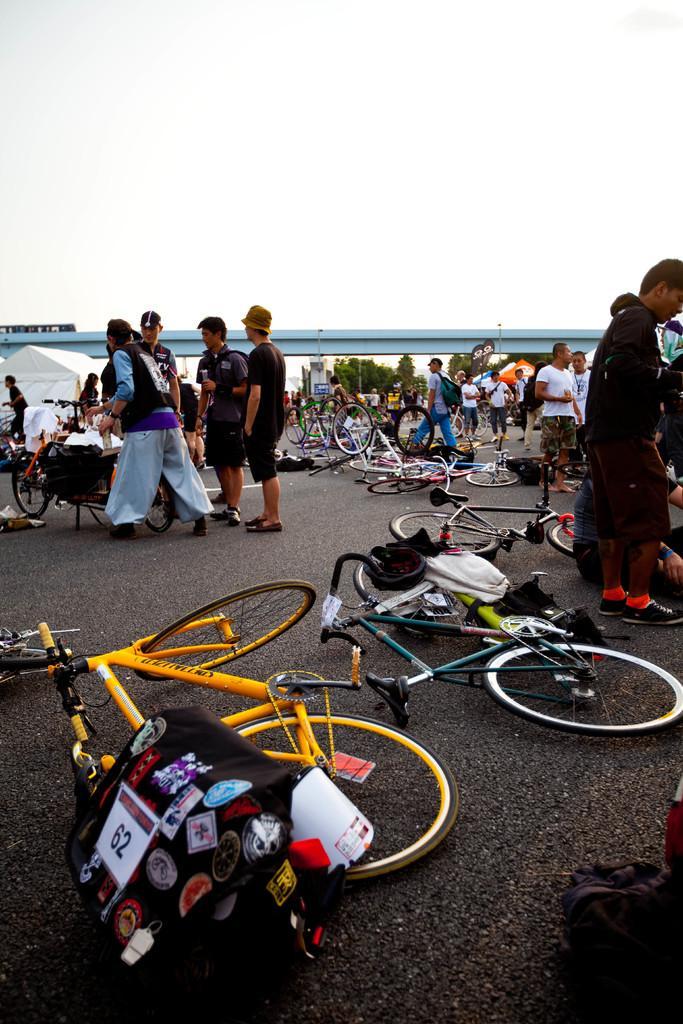Describe this image in one or two sentences. Here in this picture we can see bicycles present on the road all over there and we can see people standing and walking on the road here and there and we can see some of them are wearing caps and hats on them and in the far we can see sheda and plants and water present over there. 